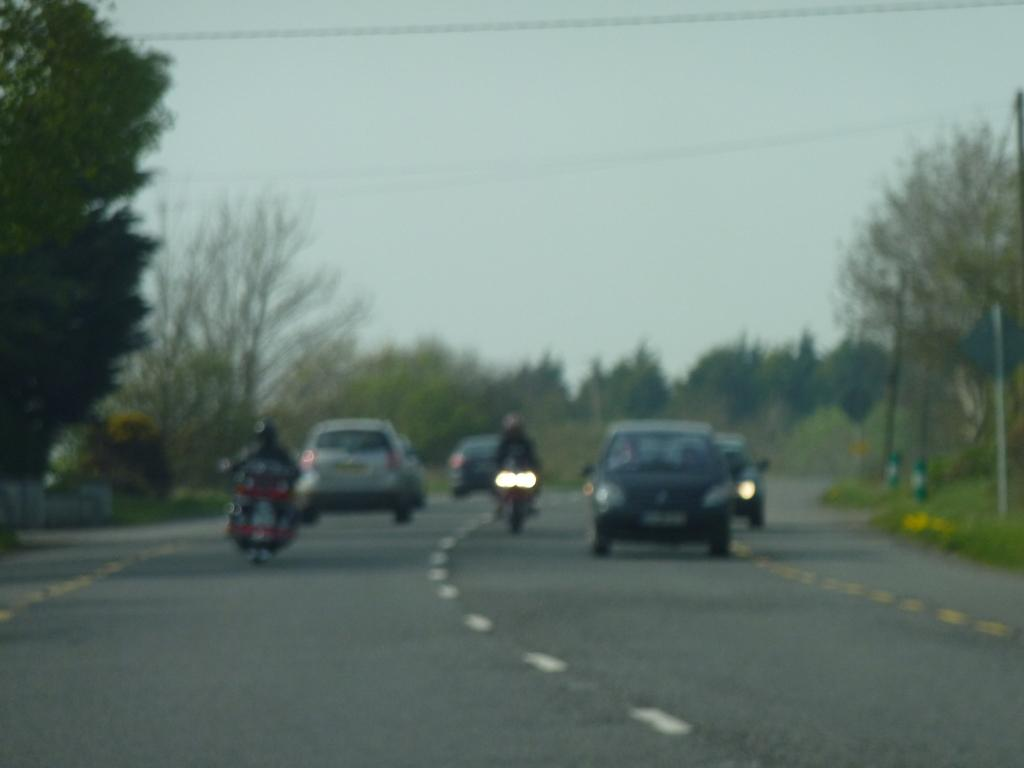What is the main subject of the image? The main subject of the image is vehicles on the road. Where are the vehicles located in the image? The vehicles are in the center of the image. What can be seen in the background of the image? There are trees and the sky visible in the background of the image. What type of fang can be seen in the image? There is no fang present in the image. How many blades are visible in the image? There are no blades visible in the image. 